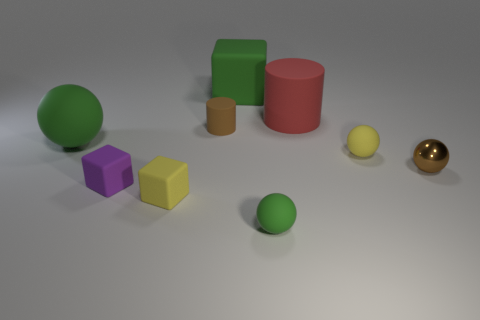How many other objects are the same color as the small metal sphere?
Provide a succinct answer. 1. Do the small brown metallic thing and the tiny matte object behind the large green rubber sphere have the same shape?
Your answer should be compact. No. Is the number of green blocks that are behind the brown metallic sphere less than the number of purple matte blocks in front of the purple matte object?
Provide a succinct answer. No. There is another thing that is the same shape as the large red object; what is its material?
Offer a very short reply. Rubber. Is there any other thing that has the same material as the red cylinder?
Offer a very short reply. Yes. Is the color of the large block the same as the tiny shiny object?
Provide a succinct answer. No. The tiny green object that is made of the same material as the small purple thing is what shape?
Provide a succinct answer. Sphere. What number of big green things are the same shape as the big red thing?
Provide a short and direct response. 0. The small yellow matte thing to the left of the block behind the red cylinder is what shape?
Provide a short and direct response. Cube. There is a yellow matte object that is right of the red rubber cylinder; is it the same size as the small cylinder?
Keep it short and to the point. Yes. 